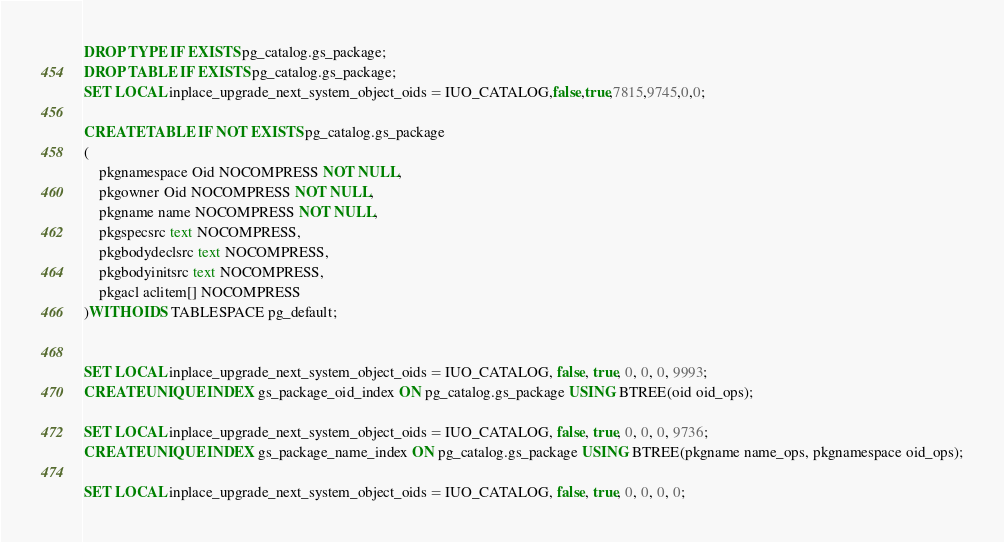<code> <loc_0><loc_0><loc_500><loc_500><_SQL_>DROP TYPE IF EXISTS pg_catalog.gs_package;
DROP TABLE IF EXISTS pg_catalog.gs_package;
SET LOCAL inplace_upgrade_next_system_object_oids = IUO_CATALOG,false,true,7815,9745,0,0;

CREATE TABLE IF NOT EXISTS pg_catalog.gs_package
(
    pkgnamespace Oid NOCOMPRESS NOT NULL,
    pkgowner Oid NOCOMPRESS NOT NULL,
    pkgname name NOCOMPRESS NOT NULL,
    pkgspecsrc text NOCOMPRESS,
    pkgbodydeclsrc text NOCOMPRESS,
    pkgbodyinitsrc text NOCOMPRESS,
    pkgacl aclitem[] NOCOMPRESS
)WITH OIDS TABLESPACE pg_default;


SET LOCAL inplace_upgrade_next_system_object_oids = IUO_CATALOG, false, true, 0, 0, 0, 9993;
CREATE UNIQUE INDEX gs_package_oid_index ON pg_catalog.gs_package USING BTREE(oid oid_ops);

SET LOCAL inplace_upgrade_next_system_object_oids = IUO_CATALOG, false, true, 0, 0, 0, 9736;
CREATE UNIQUE INDEX gs_package_name_index ON pg_catalog.gs_package USING BTREE(pkgname name_ops, pkgnamespace oid_ops);

SET LOCAL inplace_upgrade_next_system_object_oids = IUO_CATALOG, false, true, 0, 0, 0, 0;
</code> 